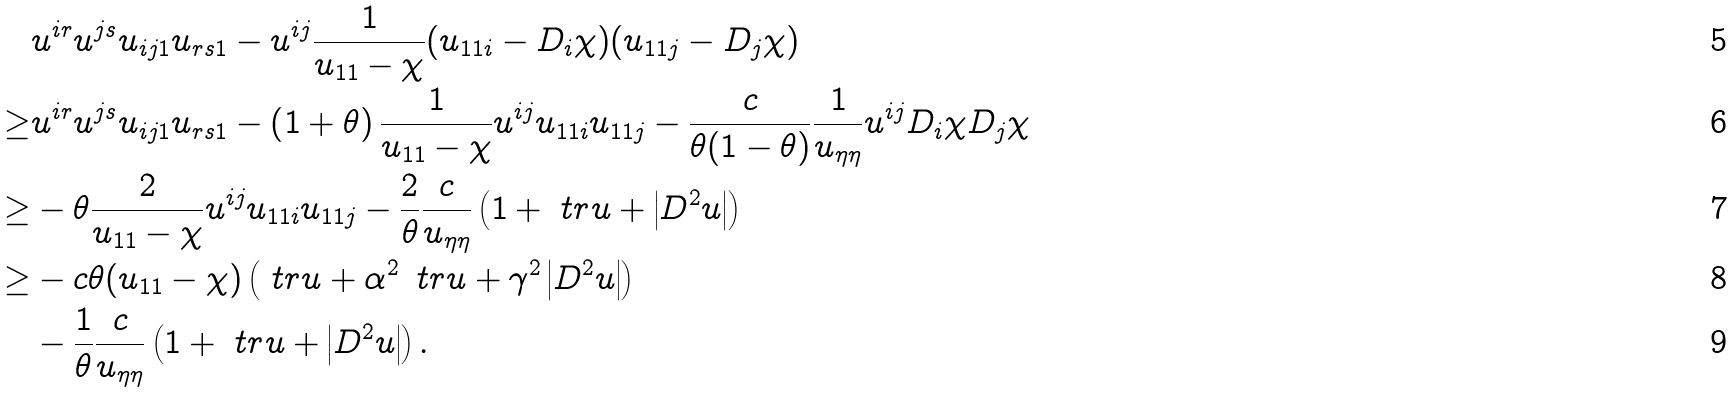<formula> <loc_0><loc_0><loc_500><loc_500>& u ^ { i r } u ^ { j s } u _ { i j 1 } u _ { r s 1 } - u ^ { i j } \frac { 1 } { u _ { 1 1 } - \chi } ( u _ { 1 1 i } - D _ { i } \chi ) ( u _ { 1 1 j } - D _ { j } \chi ) \\ \geq & u ^ { i r } u ^ { j s } u _ { i j 1 } u _ { r s 1 } - \left ( 1 + \theta \right ) \frac { 1 } { u _ { 1 1 } - \chi } u ^ { i j } u _ { 1 1 i } u _ { 1 1 j } - \frac { c } { \theta ( 1 - \theta ) } \frac { 1 } { u _ { \eta \eta } } u ^ { i j } D _ { i } \chi D _ { j } \chi \\ \geq & - \theta \frac { 2 } { u _ { 1 1 } - \chi } u ^ { i j } u _ { 1 1 i } u _ { 1 1 j } - \frac { 2 } { \theta } \frac { c } { u _ { \eta \eta } } \left ( 1 + \ t r u + \left | D ^ { 2 } u \right | \right ) \\ \geq & - c \theta ( u _ { 1 1 } - \chi ) \left ( \ t r u + \alpha ^ { 2 } \, \ t r u + \gamma ^ { 2 } \left | D ^ { 2 } u \right | \right ) \\ & - \frac { 1 } { \theta } \frac { c } { u _ { \eta \eta } } \left ( 1 + \ t r u + \left | D ^ { 2 } u \right | \right ) .</formula> 